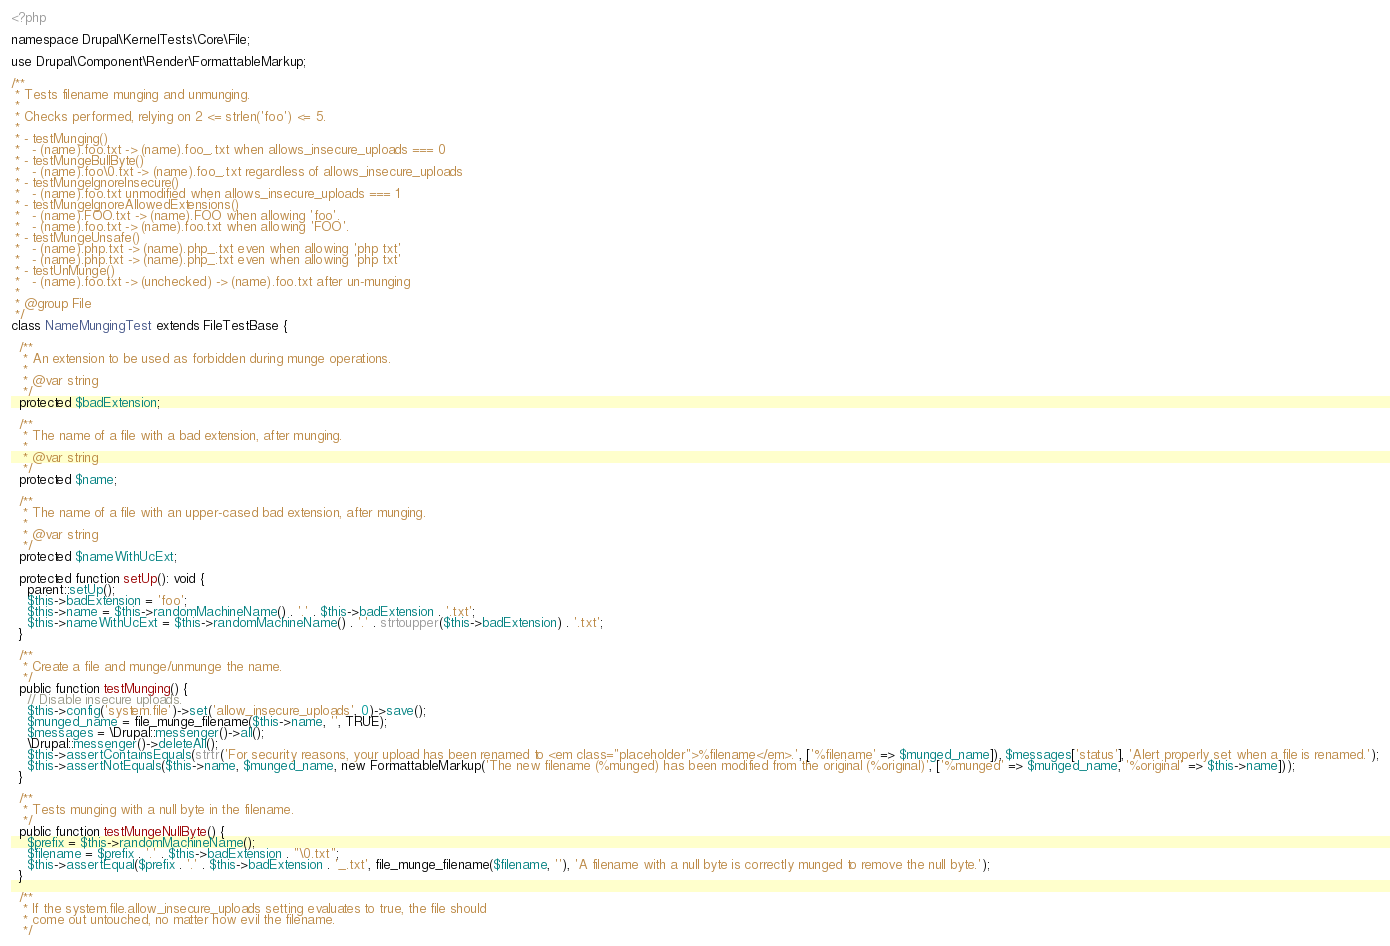Convert code to text. <code><loc_0><loc_0><loc_500><loc_500><_PHP_><?php

namespace Drupal\KernelTests\Core\File;

use Drupal\Component\Render\FormattableMarkup;

/**
 * Tests filename munging and unmunging.
 *
 * Checks performed, relying on 2 <= strlen('foo') <= 5.
 *
 * - testMunging()
 *   - (name).foo.txt -> (name).foo_.txt when allows_insecure_uploads === 0
 * - testMungeBullByte()
 *   - (name).foo\0.txt -> (name).foo_.txt regardless of allows_insecure_uploads
 * - testMungeIgnoreInsecure()
 *   - (name).foo.txt unmodified when allows_insecure_uploads === 1
 * - testMungeIgnoreAllowedExtensions()
 *   - (name).FOO.txt -> (name).FOO when allowing 'foo'.
 *   - (name).foo.txt -> (name).foo.txt when allowing 'FOO'.
 * - testMungeUnsafe()
 *   - (name).php.txt -> (name).php_.txt even when allowing 'php txt'
 *   - (name).php.txt -> (name).php_.txt even when allowing 'php txt'
 * - testUnMunge()
 *   - (name).foo.txt -> (unchecked) -> (name).foo.txt after un-munging
 *
 * @group File
 */
class NameMungingTest extends FileTestBase {

  /**
   * An extension to be used as forbidden during munge operations.
   *
   * @var string
   */
  protected $badExtension;

  /**
   * The name of a file with a bad extension, after munging.
   *
   * @var string
   */
  protected $name;

  /**
   * The name of a file with an upper-cased bad extension, after munging.
   *
   * @var string
   */
  protected $nameWithUcExt;

  protected function setUp(): void {
    parent::setUp();
    $this->badExtension = 'foo';
    $this->name = $this->randomMachineName() . '.' . $this->badExtension . '.txt';
    $this->nameWithUcExt = $this->randomMachineName() . '.' . strtoupper($this->badExtension) . '.txt';
  }

  /**
   * Create a file and munge/unmunge the name.
   */
  public function testMunging() {
    // Disable insecure uploads.
    $this->config('system.file')->set('allow_insecure_uploads', 0)->save();
    $munged_name = file_munge_filename($this->name, '', TRUE);
    $messages = \Drupal::messenger()->all();
    \Drupal::messenger()->deleteAll();
    $this->assertContainsEquals(strtr('For security reasons, your upload has been renamed to <em class="placeholder">%filename</em>.', ['%filename' => $munged_name]), $messages['status'], 'Alert properly set when a file is renamed.');
    $this->assertNotEquals($this->name, $munged_name, new FormattableMarkup('The new filename (%munged) has been modified from the original (%original)', ['%munged' => $munged_name, '%original' => $this->name]));
  }

  /**
   * Tests munging with a null byte in the filename.
   */
  public function testMungeNullByte() {
    $prefix = $this->randomMachineName();
    $filename = $prefix . '.' . $this->badExtension . "\0.txt";
    $this->assertEqual($prefix . '.' . $this->badExtension . '_.txt', file_munge_filename($filename, ''), 'A filename with a null byte is correctly munged to remove the null byte.');
  }

  /**
   * If the system.file.allow_insecure_uploads setting evaluates to true, the file should
   * come out untouched, no matter how evil the filename.
   */</code> 